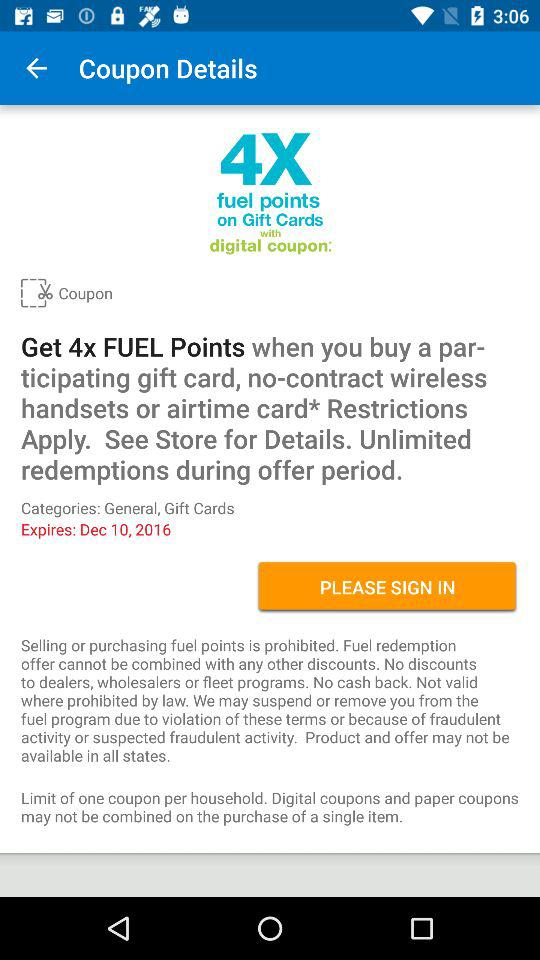What is the maximum number of fuel points that can be earned by using this coupon?
Answer the question using a single word or phrase. 4x 